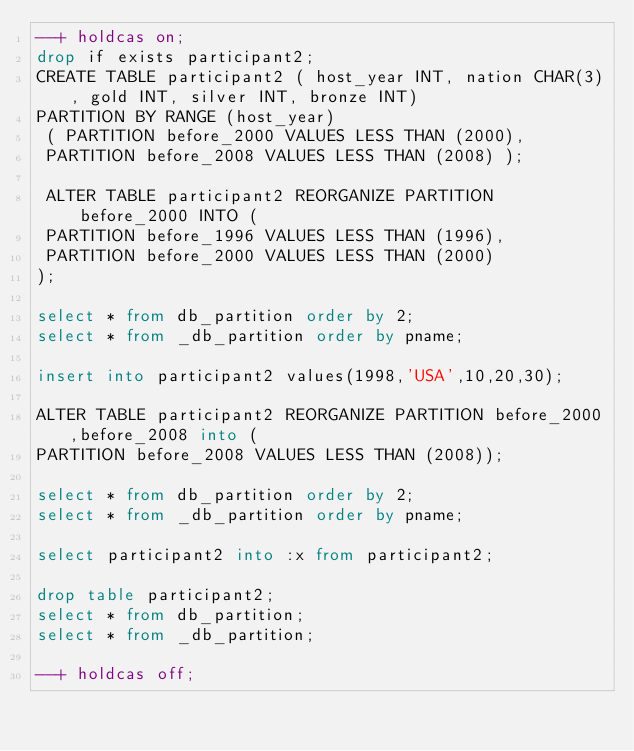<code> <loc_0><loc_0><loc_500><loc_500><_SQL_>--+ holdcas on;
drop if exists participant2;
CREATE TABLE participant2 ( host_year INT, nation CHAR(3), gold INT, silver INT, bronze INT)
PARTITION BY RANGE (host_year)
 ( PARTITION before_2000 VALUES LESS THAN (2000),
 PARTITION before_2008 VALUES LESS THAN (2008) );
 
 ALTER TABLE participant2 REORGANIZE PARTITION before_2000 INTO (
 PARTITION before_1996 VALUES LESS THAN (1996),
 PARTITION before_2000 VALUES LESS THAN (2000)
);

select * from db_partition order by 2;
select * from _db_partition order by pname;

insert into participant2 values(1998,'USA',10,20,30);

ALTER TABLE participant2 REORGANIZE PARTITION before_2000,before_2008 into (
PARTITION before_2008 VALUES LESS THAN (2008));

select * from db_partition order by 2;
select * from _db_partition order by pname;

select participant2 into :x from participant2;

drop table participant2;
select * from db_partition;
select * from _db_partition;

--+ holdcas off;
</code> 